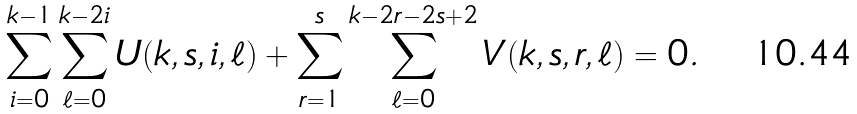Convert formula to latex. <formula><loc_0><loc_0><loc_500><loc_500>\sum _ { i = 0 } ^ { k - 1 } \sum _ { \ell = 0 } ^ { k - 2 i } U ( k , s , i , \ell ) + \sum _ { r = 1 } ^ { s } \sum _ { \ell = 0 } ^ { k - 2 r - 2 s + 2 } V ( k , s , r , \ell ) = 0 .</formula> 